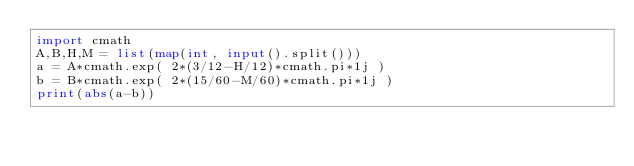<code> <loc_0><loc_0><loc_500><loc_500><_Python_>import cmath
A,B,H,M = list(map(int, input().split()))
a = A*cmath.exp( 2*(3/12-H/12)*cmath.pi*1j )
b = B*cmath.exp( 2*(15/60-M/60)*cmath.pi*1j )
print(abs(a-b))</code> 